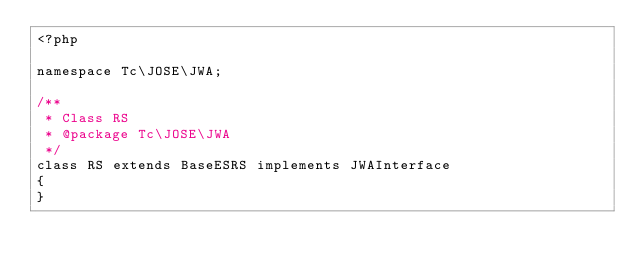Convert code to text. <code><loc_0><loc_0><loc_500><loc_500><_PHP_><?php

namespace Tc\JOSE\JWA;

/**
 * Class RS
 * @package Tc\JOSE\JWA
 */
class RS extends BaseESRS implements JWAInterface
{
}
</code> 